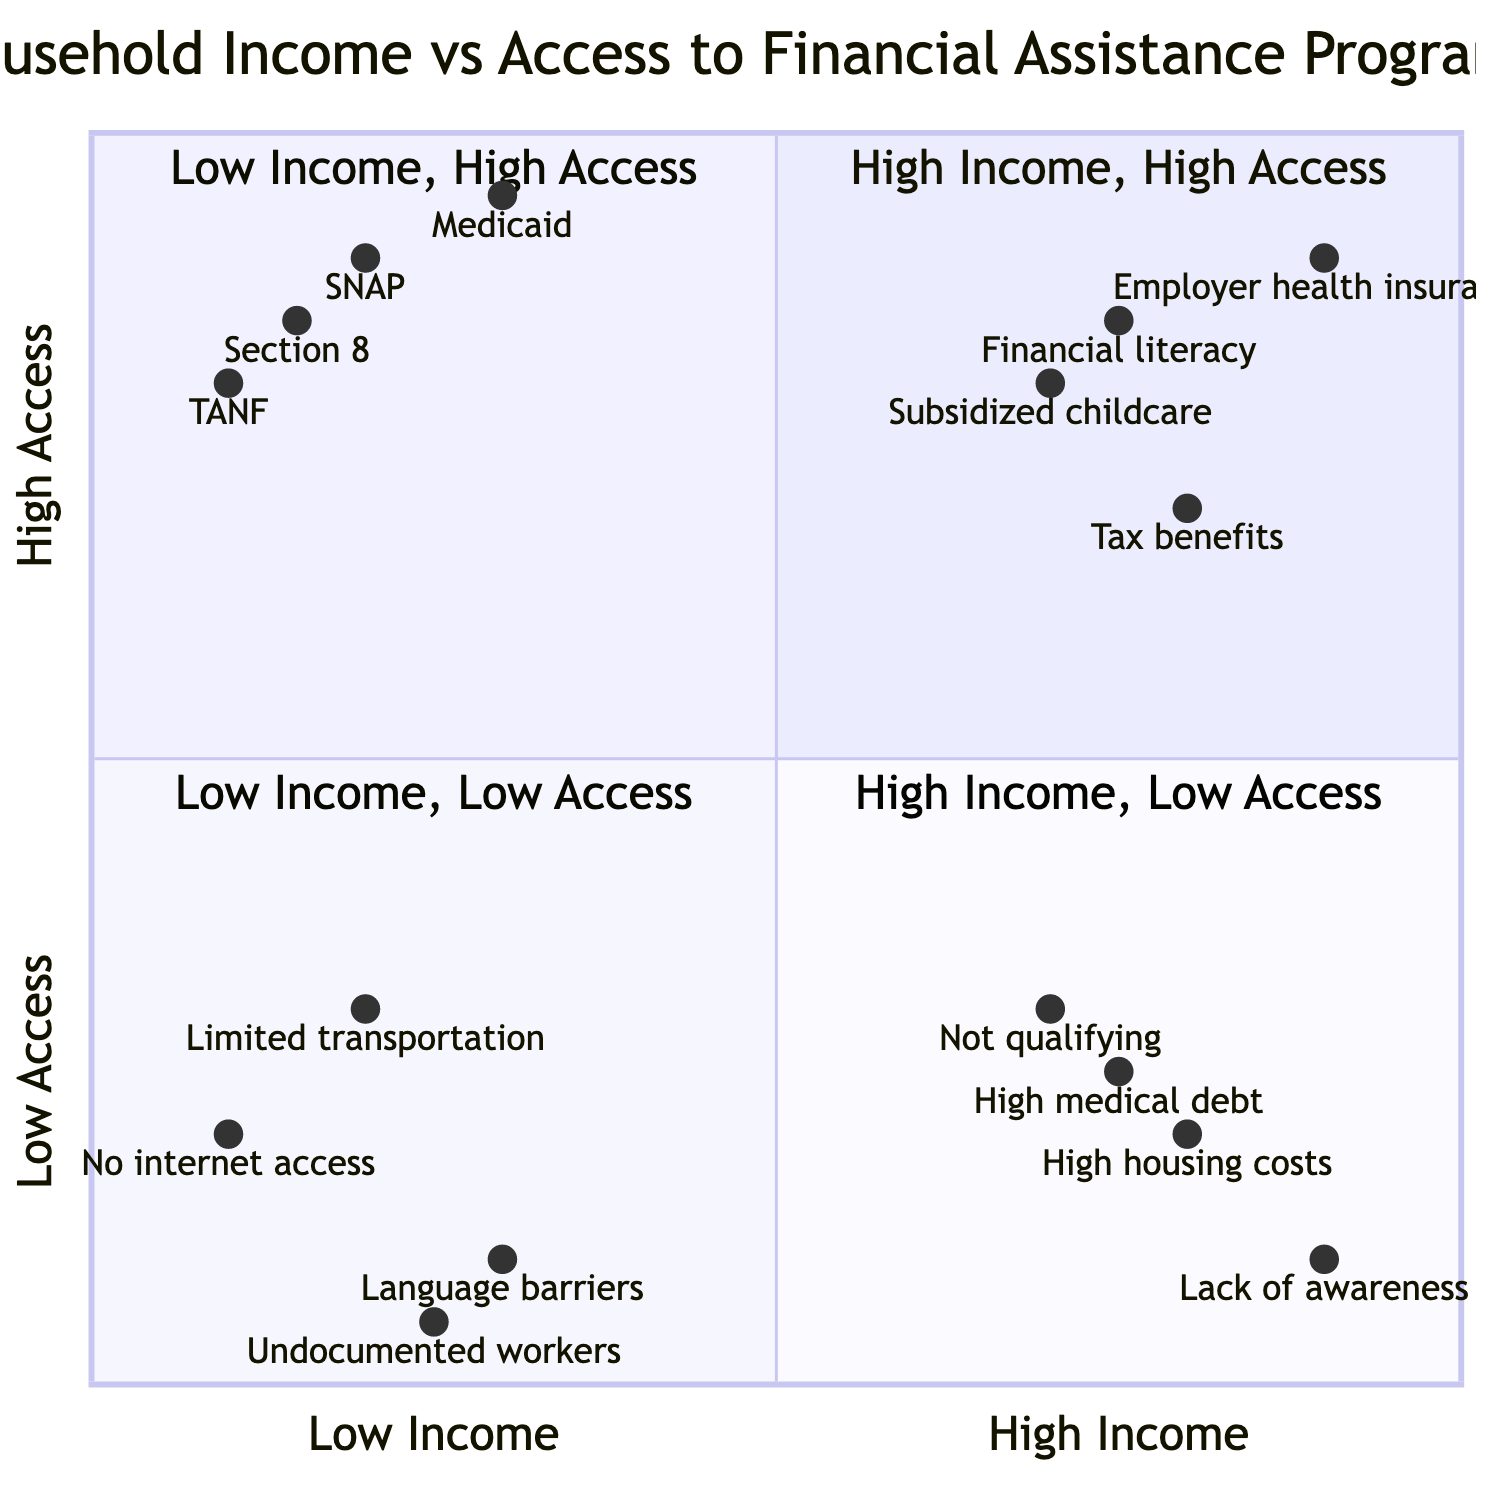What financial assistance programs are classified under Low Income, High Access? The quadrant titled "Low Income, High Access" lists the financial assistance programs available to low-income households that have high access to help. These programs mentioned in this quadrant are: Supplemental Nutrition Assistance Program (SNAP), Temporary Assistance for Needy Families (TANF), Medicaid, and Housing Choice Voucher Program (Section 8).
Answer: SNAP, TANF, Medicaid, Housing Choice Voucher Program (Section 8) How many elements are in the High Income, Low Access quadrant? This quadrant contains multiple elements detailing families who have high income but low access to assistance. By counting the listed elements—Families not qualifying for need-based assistance, High housing costs limiting eligibility for programs, Lack of awareness about available assistance programs, and Middle-income families with high medical debt—it is clear that there are four elements total.
Answer: 4 Which quadrant contains families with language barriers? Families with language barriers are mentioned in the "Low Income, Low Access" quadrant. This means they experience both low income and limited access to assistance due to linguistic challenges.
Answer: Low Income, Low Access What does the presence of "Employer-sponsored health insurance" indicate about the relationship between income and access to programs? "Employer-sponsored health insurance" is included in the "High Income, High Access" quadrant, indicating that higher-income families tend to have better access to financial assistance and support programs compared to low-income families. This supports the correlation that as income increases, access to resources and programs also increases.
Answer: Positive correlation What is a notable barrier for families classified under Low Income, Low Access? Several elements represent notable barriers for families in the "Low Income, Low Access" quadrant. One significant barrier is "Single-parent households without internet access," which indicates limited information and resources regarding assistance, thereby exacerbating their challenges.
Answer: Single-parent households without internet access 